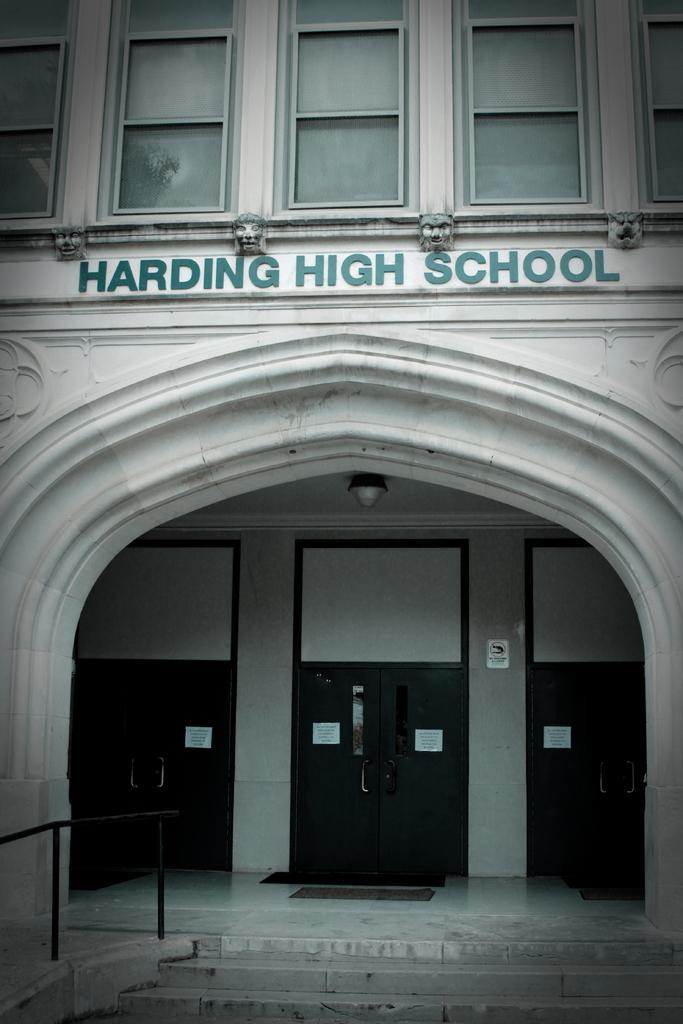Describe this image in one or two sentences. In this picture I can see a building in front and on the bottom of this picture I can see the railing and the steps. In the middle of this picture I see 3 words written. 